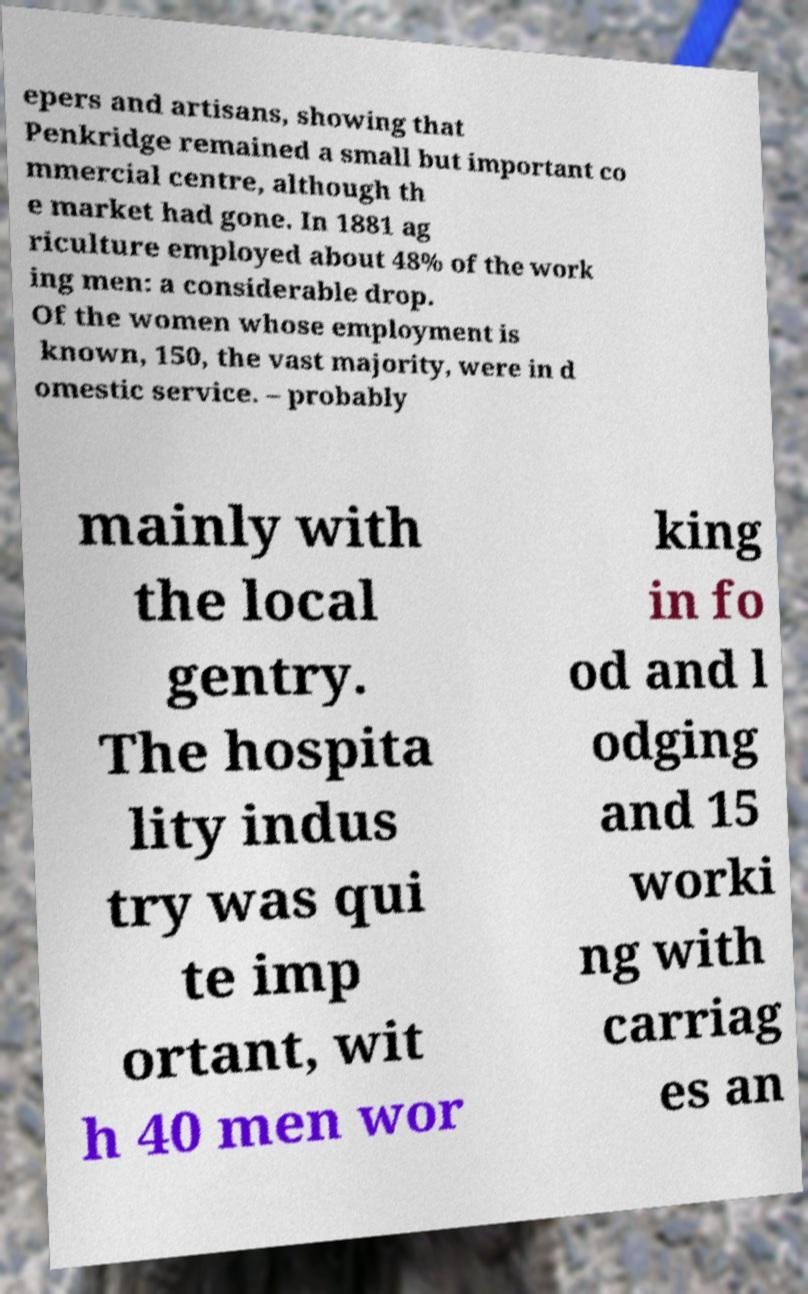What messages or text are displayed in this image? I need them in a readable, typed format. epers and artisans, showing that Penkridge remained a small but important co mmercial centre, although th e market had gone. In 1881 ag riculture employed about 48% of the work ing men: a considerable drop. Of the women whose employment is known, 150, the vast majority, were in d omestic service. – probably mainly with the local gentry. The hospita lity indus try was qui te imp ortant, wit h 40 men wor king in fo od and l odging and 15 worki ng with carriag es an 